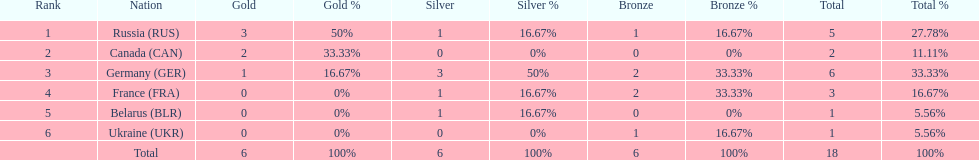What are all the countries in the 1994 winter olympics biathlon? Russia (RUS), Canada (CAN), Germany (GER), France (FRA), Belarus (BLR), Ukraine (UKR). Which of these received at least one gold medal? Russia (RUS), Canada (CAN), Germany (GER). Which of these received no silver or bronze medals? Canada (CAN). 